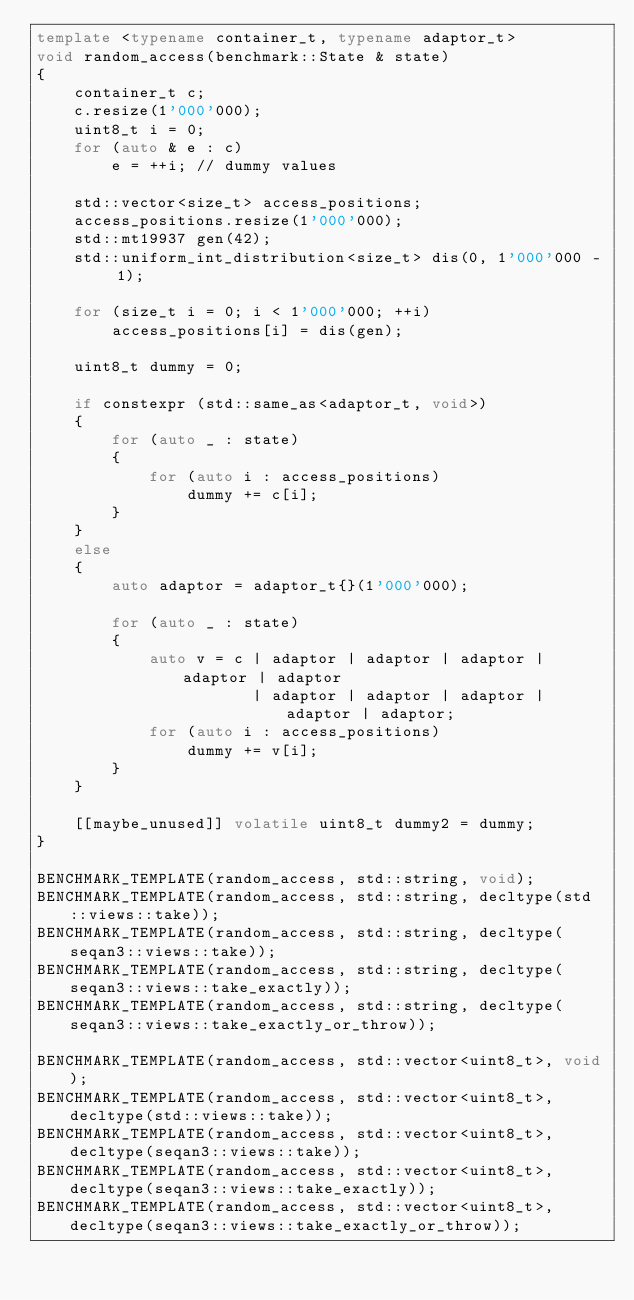Convert code to text. <code><loc_0><loc_0><loc_500><loc_500><_C++_>template <typename container_t, typename adaptor_t>
void random_access(benchmark::State & state)
{
    container_t c;
    c.resize(1'000'000);
    uint8_t i = 0;
    for (auto & e : c)
        e = ++i; // dummy values

    std::vector<size_t> access_positions;
    access_positions.resize(1'000'000);
    std::mt19937 gen(42);
    std::uniform_int_distribution<size_t> dis(0, 1'000'000 - 1);

    for (size_t i = 0; i < 1'000'000; ++i)
        access_positions[i] = dis(gen);

    uint8_t dummy = 0;

    if constexpr (std::same_as<adaptor_t, void>)
    {
        for (auto _ : state)
        {
            for (auto i : access_positions)
                dummy += c[i];
        }
    }
    else
    {
        auto adaptor = adaptor_t{}(1'000'000);

        for (auto _ : state)
        {
            auto v = c | adaptor | adaptor | adaptor | adaptor | adaptor
                       | adaptor | adaptor | adaptor | adaptor | adaptor;
            for (auto i : access_positions)
                dummy += v[i];
        }
    }

    [[maybe_unused]] volatile uint8_t dummy2 = dummy;
}

BENCHMARK_TEMPLATE(random_access, std::string, void);
BENCHMARK_TEMPLATE(random_access, std::string, decltype(std::views::take));
BENCHMARK_TEMPLATE(random_access, std::string, decltype(seqan3::views::take));
BENCHMARK_TEMPLATE(random_access, std::string, decltype(seqan3::views::take_exactly));
BENCHMARK_TEMPLATE(random_access, std::string, decltype(seqan3::views::take_exactly_or_throw));

BENCHMARK_TEMPLATE(random_access, std::vector<uint8_t>, void);
BENCHMARK_TEMPLATE(random_access, std::vector<uint8_t>, decltype(std::views::take));
BENCHMARK_TEMPLATE(random_access, std::vector<uint8_t>, decltype(seqan3::views::take));
BENCHMARK_TEMPLATE(random_access, std::vector<uint8_t>, decltype(seqan3::views::take_exactly));
BENCHMARK_TEMPLATE(random_access, std::vector<uint8_t>, decltype(seqan3::views::take_exactly_or_throw));
</code> 